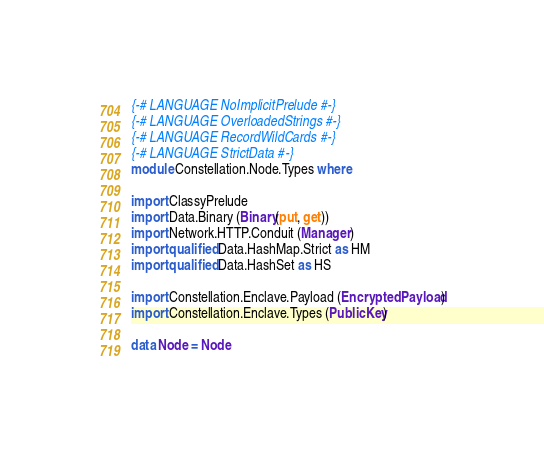<code> <loc_0><loc_0><loc_500><loc_500><_Haskell_>{-# LANGUAGE NoImplicitPrelude #-}
{-# LANGUAGE OverloadedStrings #-}
{-# LANGUAGE RecordWildCards #-}
{-# LANGUAGE StrictData #-}
module Constellation.Node.Types where

import ClassyPrelude
import Data.Binary (Binary(put, get))
import Network.HTTP.Conduit (Manager)
import qualified Data.HashMap.Strict as HM
import qualified Data.HashSet as HS

import Constellation.Enclave.Payload (EncryptedPayload)
import Constellation.Enclave.Types (PublicKey)

data Node = Node</code> 